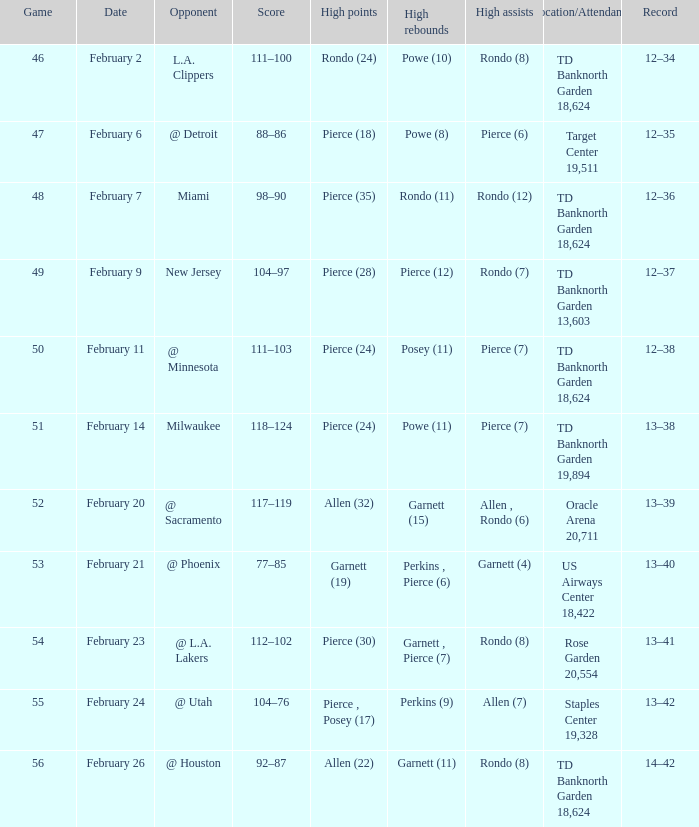How many games with high rebounds where in february 26 1.0. 